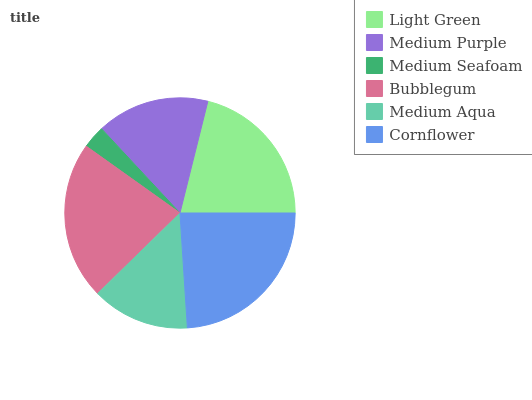Is Medium Seafoam the minimum?
Answer yes or no. Yes. Is Cornflower the maximum?
Answer yes or no. Yes. Is Medium Purple the minimum?
Answer yes or no. No. Is Medium Purple the maximum?
Answer yes or no. No. Is Light Green greater than Medium Purple?
Answer yes or no. Yes. Is Medium Purple less than Light Green?
Answer yes or no. Yes. Is Medium Purple greater than Light Green?
Answer yes or no. No. Is Light Green less than Medium Purple?
Answer yes or no. No. Is Light Green the high median?
Answer yes or no. Yes. Is Medium Purple the low median?
Answer yes or no. Yes. Is Medium Seafoam the high median?
Answer yes or no. No. Is Medium Aqua the low median?
Answer yes or no. No. 